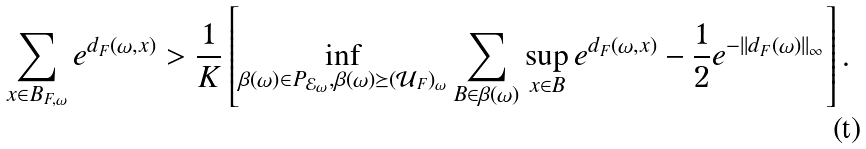Convert formula to latex. <formula><loc_0><loc_0><loc_500><loc_500>\sum _ { x \in B _ { F , \omega } } e ^ { d _ { F } ( \omega , x ) } > \frac { 1 } { K } \left [ \inf _ { \beta ( \omega ) \in P _ { \mathcal { E } _ { \omega } } , \beta ( \omega ) \succeq ( \mathcal { U } _ { F } ) _ { \omega } } \sum _ { B \in \beta ( \omega ) } \sup _ { x \in B } e ^ { d _ { F } ( \omega , x ) } - \frac { 1 } { 2 } e ^ { - | | d _ { F } ( \omega ) | | _ { \infty } } \right ] .</formula> 